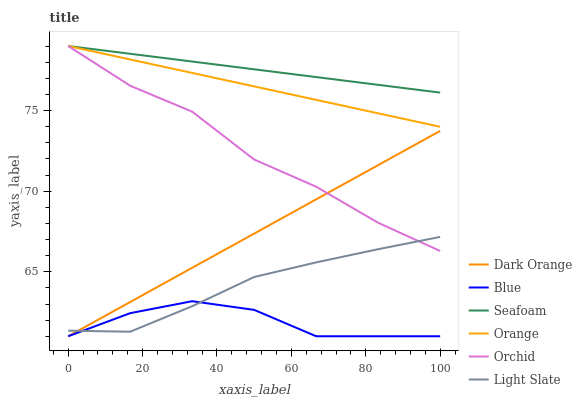Does Blue have the minimum area under the curve?
Answer yes or no. Yes. Does Seafoam have the maximum area under the curve?
Answer yes or no. Yes. Does Dark Orange have the minimum area under the curve?
Answer yes or no. No. Does Dark Orange have the maximum area under the curve?
Answer yes or no. No. Is Orange the smoothest?
Answer yes or no. Yes. Is Blue the roughest?
Answer yes or no. Yes. Is Dark Orange the smoothest?
Answer yes or no. No. Is Dark Orange the roughest?
Answer yes or no. No. Does Blue have the lowest value?
Answer yes or no. Yes. Does Light Slate have the lowest value?
Answer yes or no. No. Does Orchid have the highest value?
Answer yes or no. Yes. Does Dark Orange have the highest value?
Answer yes or no. No. Is Blue less than Orange?
Answer yes or no. Yes. Is Seafoam greater than Light Slate?
Answer yes or no. Yes. Does Orange intersect Orchid?
Answer yes or no. Yes. Is Orange less than Orchid?
Answer yes or no. No. Is Orange greater than Orchid?
Answer yes or no. No. Does Blue intersect Orange?
Answer yes or no. No. 